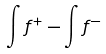Convert formula to latex. <formula><loc_0><loc_0><loc_500><loc_500>\int f ^ { + } - \int f ^ { - }</formula> 